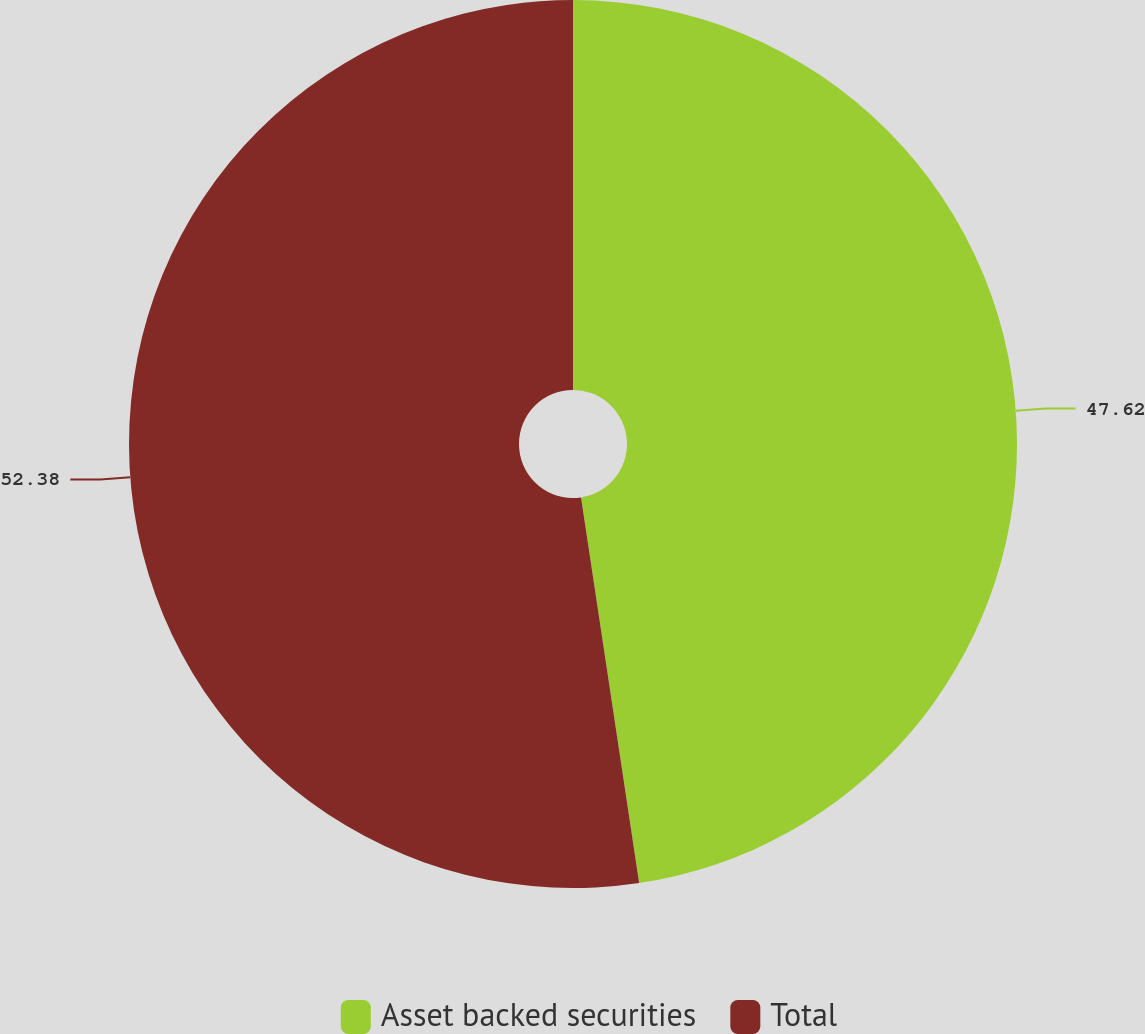<chart> <loc_0><loc_0><loc_500><loc_500><pie_chart><fcel>Asset backed securities<fcel>Total<nl><fcel>47.62%<fcel>52.38%<nl></chart> 